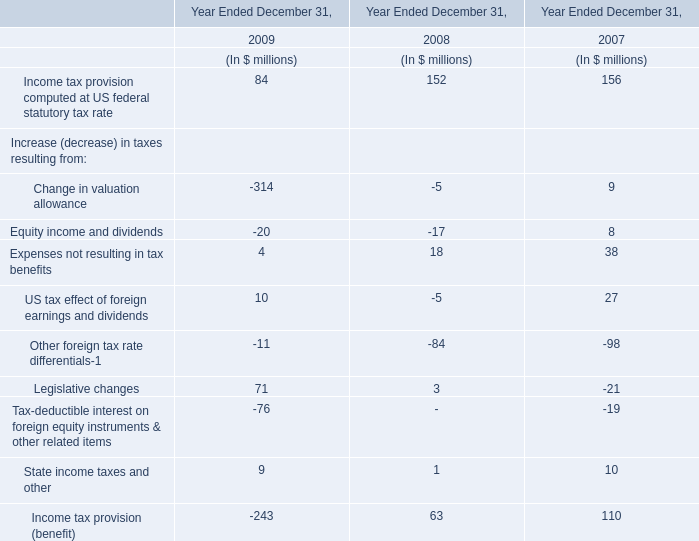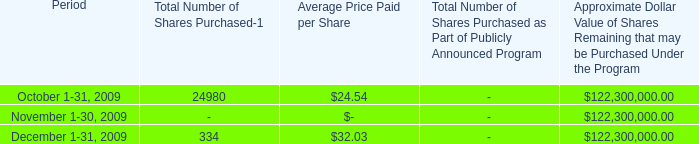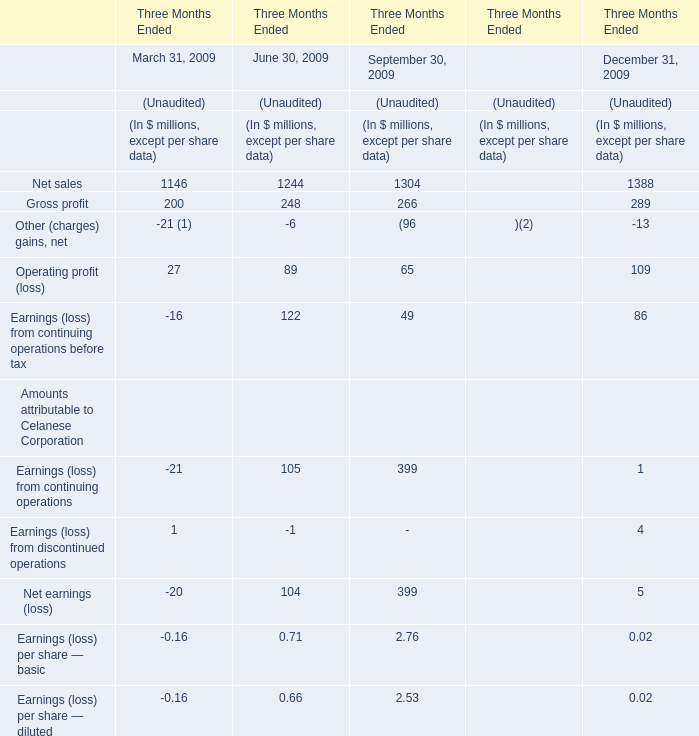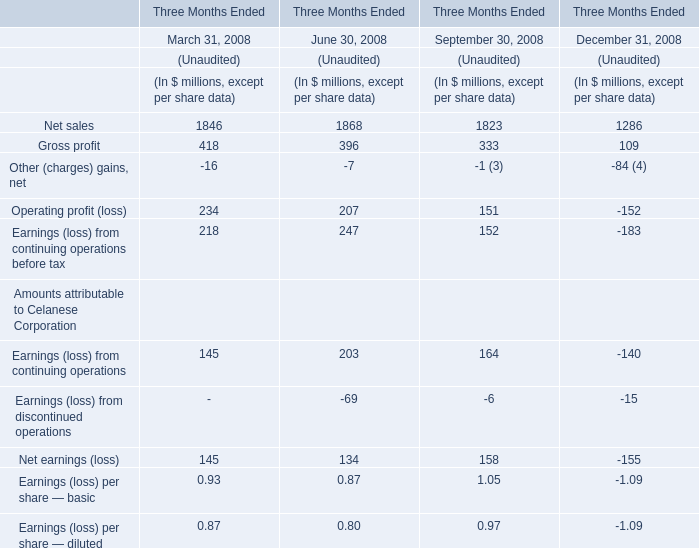What was the average value of Net sales, Gross profit, Other (charges) gains, net for March 31, 2008 ? (in million) 
Computations: (((1846 + 418) - 16) / 3)
Answer: 749.33333. 